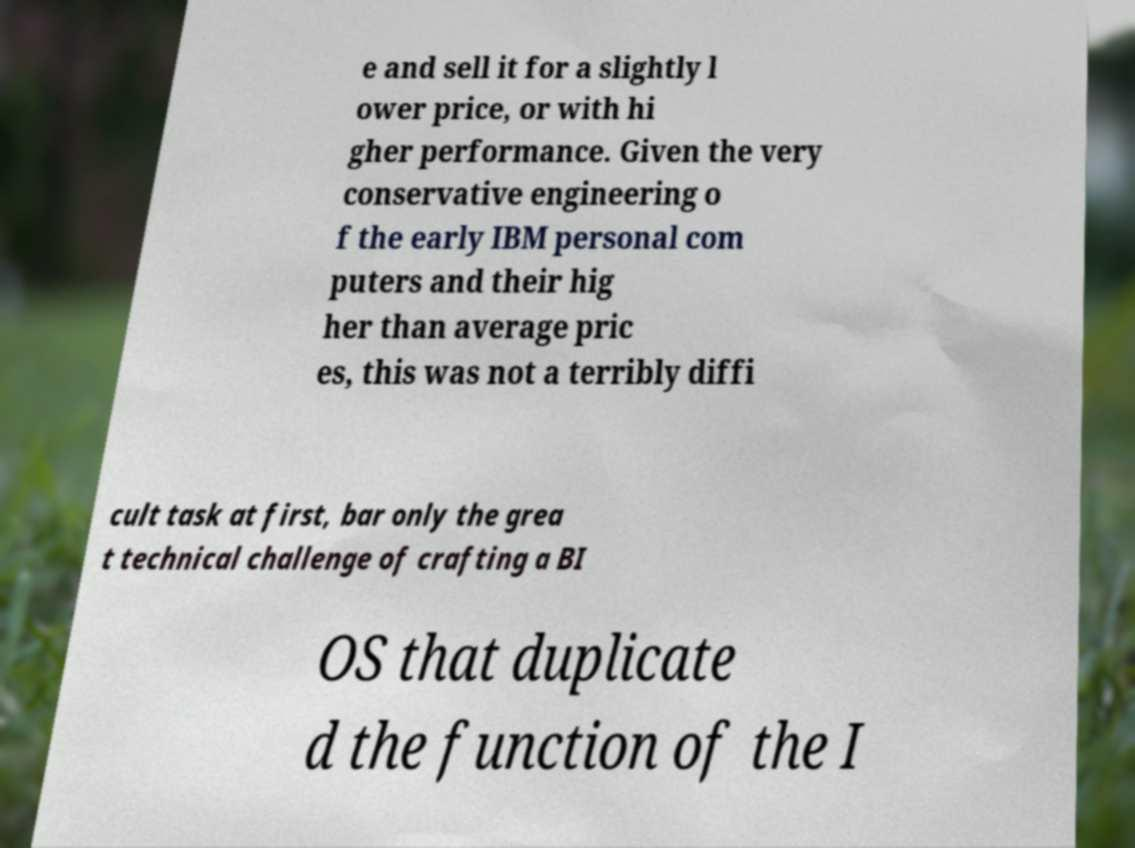Could you assist in decoding the text presented in this image and type it out clearly? e and sell it for a slightly l ower price, or with hi gher performance. Given the very conservative engineering o f the early IBM personal com puters and their hig her than average pric es, this was not a terribly diffi cult task at first, bar only the grea t technical challenge of crafting a BI OS that duplicate d the function of the I 